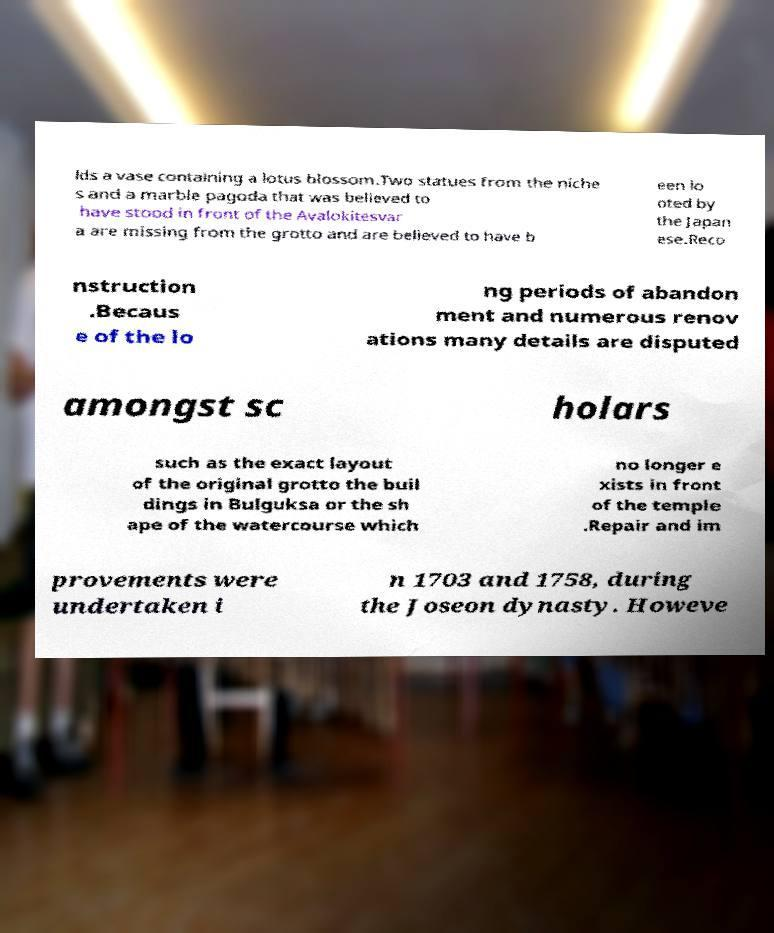I need the written content from this picture converted into text. Can you do that? lds a vase containing a lotus blossom.Two statues from the niche s and a marble pagoda that was believed to have stood in front of the Avalokitesvar a are missing from the grotto and are believed to have b een lo oted by the Japan ese.Reco nstruction .Becaus e of the lo ng periods of abandon ment and numerous renov ations many details are disputed amongst sc holars such as the exact layout of the original grotto the buil dings in Bulguksa or the sh ape of the watercourse which no longer e xists in front of the temple .Repair and im provements were undertaken i n 1703 and 1758, during the Joseon dynasty. Howeve 